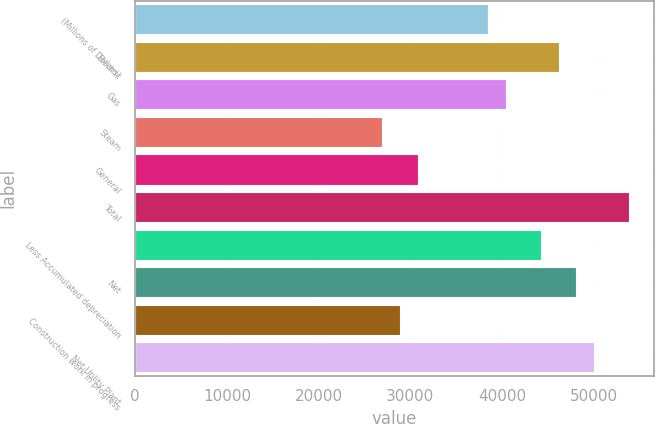Convert chart. <chart><loc_0><loc_0><loc_500><loc_500><bar_chart><fcel>(Millions of Dollars)<fcel>Electric<fcel>Gas<fcel>Steam<fcel>General<fcel>Total<fcel>Less Accumulated depreciation<fcel>Net<fcel>Construction work in progress<fcel>Net Utility Plant<nl><fcel>38485<fcel>46181.4<fcel>40409.1<fcel>26940.4<fcel>30788.6<fcel>53877.8<fcel>44257.3<fcel>48105.5<fcel>28864.5<fcel>50029.6<nl></chart> 